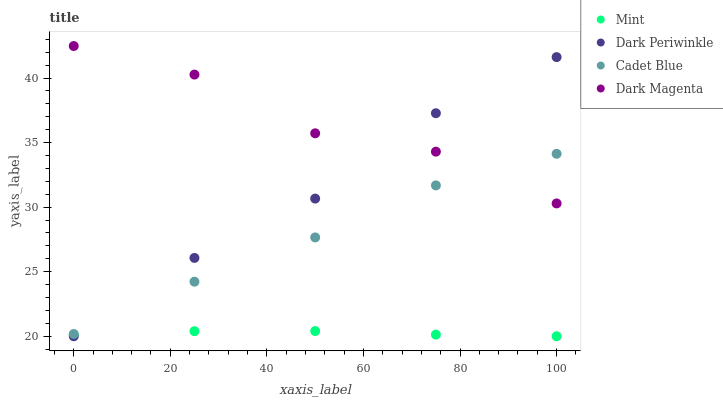Does Mint have the minimum area under the curve?
Answer yes or no. Yes. Does Dark Magenta have the maximum area under the curve?
Answer yes or no. Yes. Does Dark Periwinkle have the minimum area under the curve?
Answer yes or no. No. Does Dark Periwinkle have the maximum area under the curve?
Answer yes or no. No. Is Mint the smoothest?
Answer yes or no. Yes. Is Dark Magenta the roughest?
Answer yes or no. Yes. Is Dark Periwinkle the smoothest?
Answer yes or no. No. Is Dark Periwinkle the roughest?
Answer yes or no. No. Does Mint have the lowest value?
Answer yes or no. Yes. Does Dark Magenta have the lowest value?
Answer yes or no. No. Does Dark Magenta have the highest value?
Answer yes or no. Yes. Does Dark Periwinkle have the highest value?
Answer yes or no. No. Is Mint less than Dark Magenta?
Answer yes or no. Yes. Is Dark Magenta greater than Mint?
Answer yes or no. Yes. Does Dark Periwinkle intersect Dark Magenta?
Answer yes or no. Yes. Is Dark Periwinkle less than Dark Magenta?
Answer yes or no. No. Is Dark Periwinkle greater than Dark Magenta?
Answer yes or no. No. Does Mint intersect Dark Magenta?
Answer yes or no. No. 